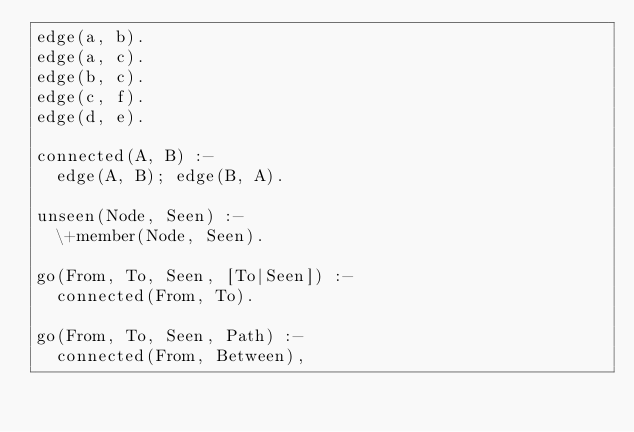Convert code to text. <code><loc_0><loc_0><loc_500><loc_500><_Perl_>edge(a, b).
edge(a, c).
edge(b, c).
edge(c, f).
edge(d, e).

connected(A, B) :-
  edge(A, B); edge(B, A).

unseen(Node, Seen) :-
  \+member(Node, Seen).

go(From, To, Seen, [To|Seen]) :-
  connected(From, To).

go(From, To, Seen, Path) :-
  connected(From, Between),</code> 